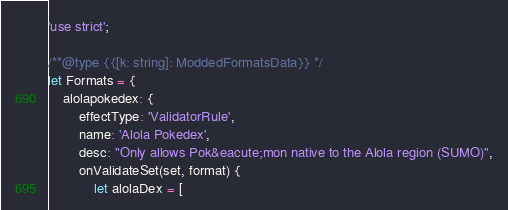<code> <loc_0><loc_0><loc_500><loc_500><_JavaScript_>'use strict';

/**@type {{[k: string]: ModdedFormatsData}} */
let Formats = {
	alolapokedex: {
		effectType: 'ValidatorRule',
		name: 'Alola Pokedex',
		desc: "Only allows Pok&eacute;mon native to the Alola region (SUMO)",
		onValidateSet(set, format) {
			let alolaDex = [</code> 